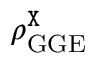Convert formula to latex. <formula><loc_0><loc_0><loc_500><loc_500>\rho _ { G G E } ^ { \tt X }</formula> 